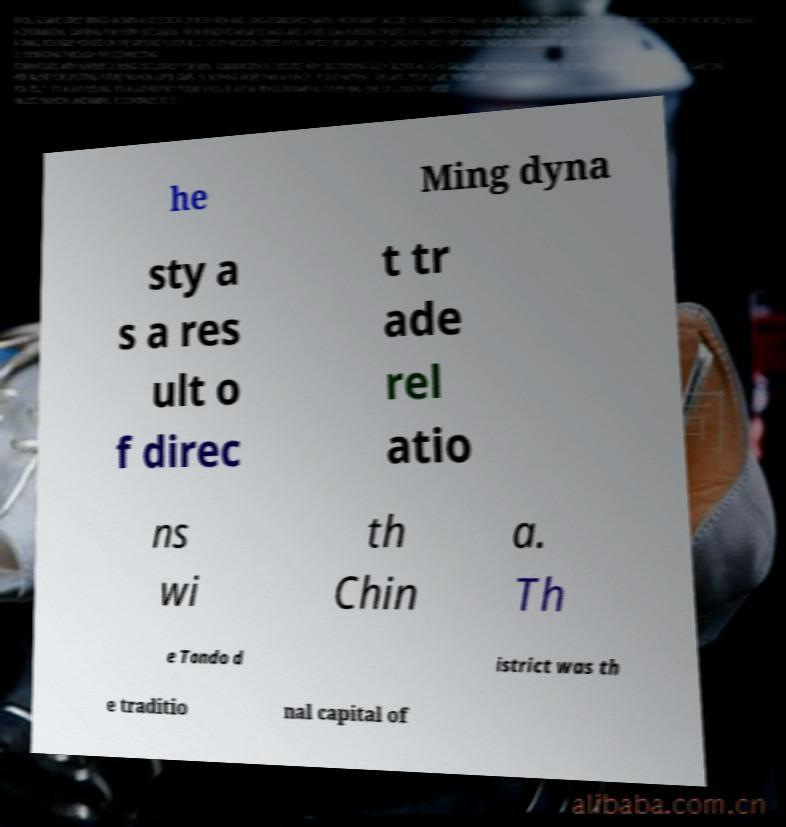Can you accurately transcribe the text from the provided image for me? he Ming dyna sty a s a res ult o f direc t tr ade rel atio ns wi th Chin a. Th e Tondo d istrict was th e traditio nal capital of 